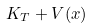<formula> <loc_0><loc_0><loc_500><loc_500>K _ { T } + V ( x )</formula> 